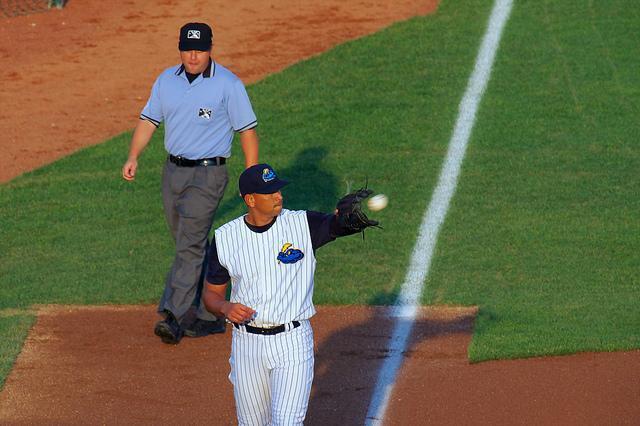How many people are there?
Give a very brief answer. 2. 